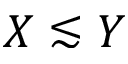<formula> <loc_0><loc_0><loc_500><loc_500>X \lesssim Y</formula> 